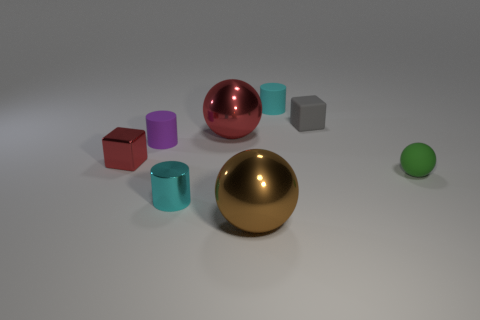Subtract all metallic spheres. How many spheres are left? 1 Add 1 cyan metallic cylinders. How many objects exist? 9 Subtract all green spheres. How many spheres are left? 2 Subtract all red cubes. How many cyan cylinders are left? 2 Subtract all blocks. How many objects are left? 6 Subtract 0 blue balls. How many objects are left? 8 Subtract 2 blocks. How many blocks are left? 0 Subtract all cyan cubes. Subtract all yellow cylinders. How many cubes are left? 2 Subtract all big red spheres. Subtract all purple matte cylinders. How many objects are left? 6 Add 1 big red metal balls. How many big red metal balls are left? 2 